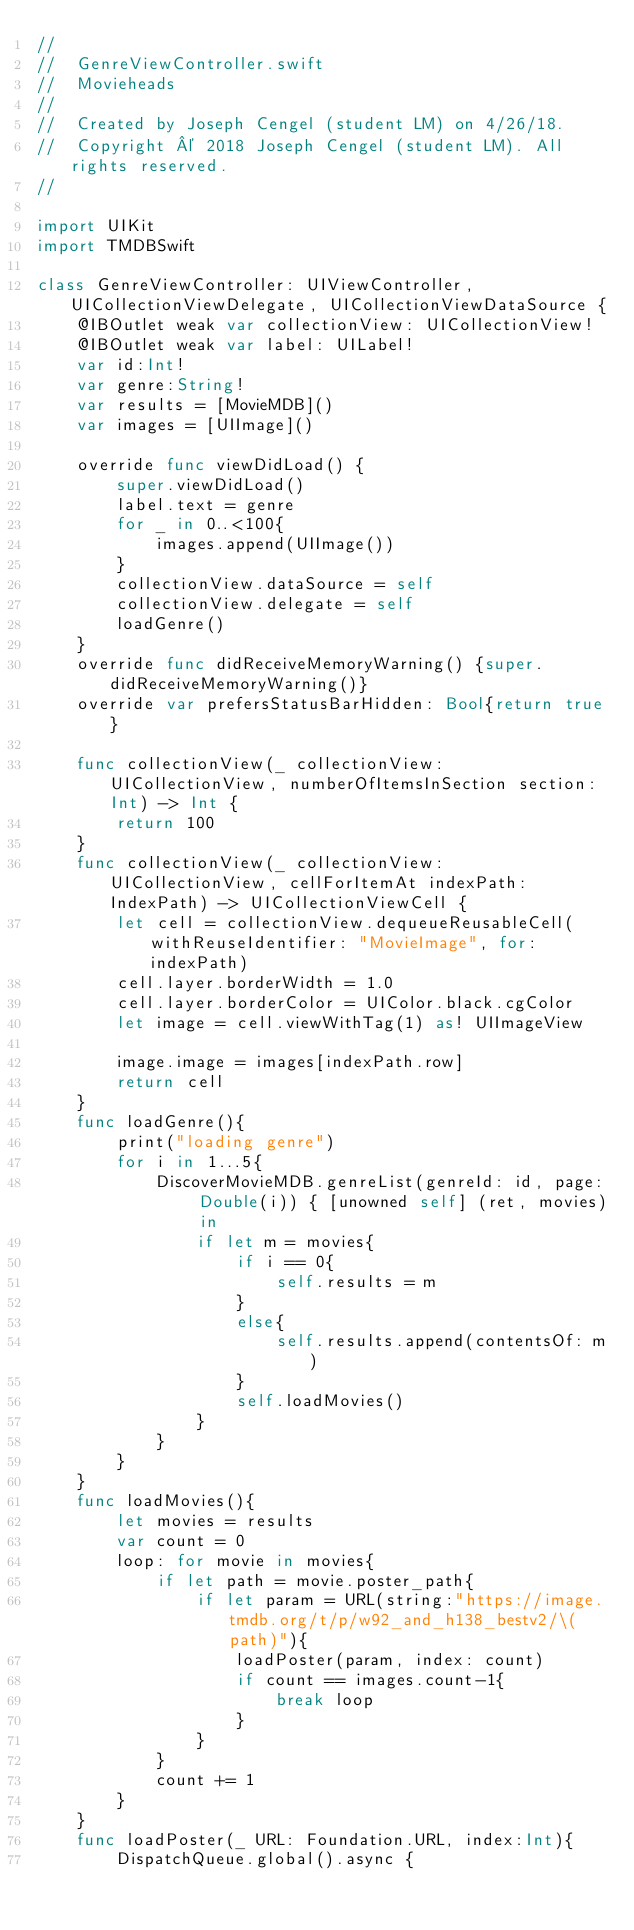Convert code to text. <code><loc_0><loc_0><loc_500><loc_500><_Swift_>//
//  GenreViewController.swift
//  Movieheads
//
//  Created by Joseph Cengel (student LM) on 4/26/18.
//  Copyright © 2018 Joseph Cengel (student LM). All rights reserved.
//

import UIKit
import TMDBSwift

class GenreViewController: UIViewController, UICollectionViewDelegate, UICollectionViewDataSource {
	@IBOutlet weak var collectionView: UICollectionView!
	@IBOutlet weak var label: UILabel!
	var id:Int!
	var genre:String!
	var results = [MovieMDB]()
	var images = [UIImage]()

    override func viewDidLoad() {
        super.viewDidLoad()
		label.text = genre
		for _ in 0..<100{
			images.append(UIImage())
		}
		collectionView.dataSource = self
		collectionView.delegate = self
		loadGenre()
    }
    override func didReceiveMemoryWarning() {super.didReceiveMemoryWarning()}
	override var prefersStatusBarHidden: Bool{return true}
	
	func collectionView(_ collectionView: UICollectionView, numberOfItemsInSection section: Int) -> Int {
		return 100
	}
	func collectionView(_ collectionView: UICollectionView, cellForItemAt indexPath: IndexPath) -> UICollectionViewCell {
		let cell = collectionView.dequeueReusableCell(withReuseIdentifier: "MovieImage", for: indexPath)
		cell.layer.borderWidth = 1.0
		cell.layer.borderColor = UIColor.black.cgColor
		let image = cell.viewWithTag(1) as! UIImageView
	
		image.image = images[indexPath.row]
		return cell
	}
	func loadGenre(){
		print("loading genre")
		for i in 1...5{
			DiscoverMovieMDB.genreList(genreId: id, page: Double(i)) { [unowned self] (ret, movies) in
				if let m = movies{
					if i == 0{
						self.results = m
					}
					else{
						self.results.append(contentsOf: m)
					}
					self.loadMovies()
				}
			}
		}
	}
	func loadMovies(){
		let movies = results
		var count = 0
		loop: for movie in movies{
			if let path = movie.poster_path{
				if let param = URL(string:"https://image.tmdb.org/t/p/w92_and_h138_bestv2/\(path)"){
					loadPoster(param, index: count)
					if count == images.count-1{
						break loop
					}
				}
			}
			count += 1
		}
	}
	func loadPoster(_ URL: Foundation.URL, index:Int){
		DispatchQueue.global().async {</code> 